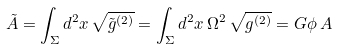<formula> <loc_0><loc_0><loc_500><loc_500>\tilde { A } = \int _ { \Sigma } d ^ { 2 } x \, \sqrt { \tilde { g } ^ { ( 2 ) } } = \int _ { \Sigma } d ^ { 2 } x \, \Omega ^ { 2 } \, \sqrt { g ^ { ( 2 ) } } = G \phi \, A</formula> 